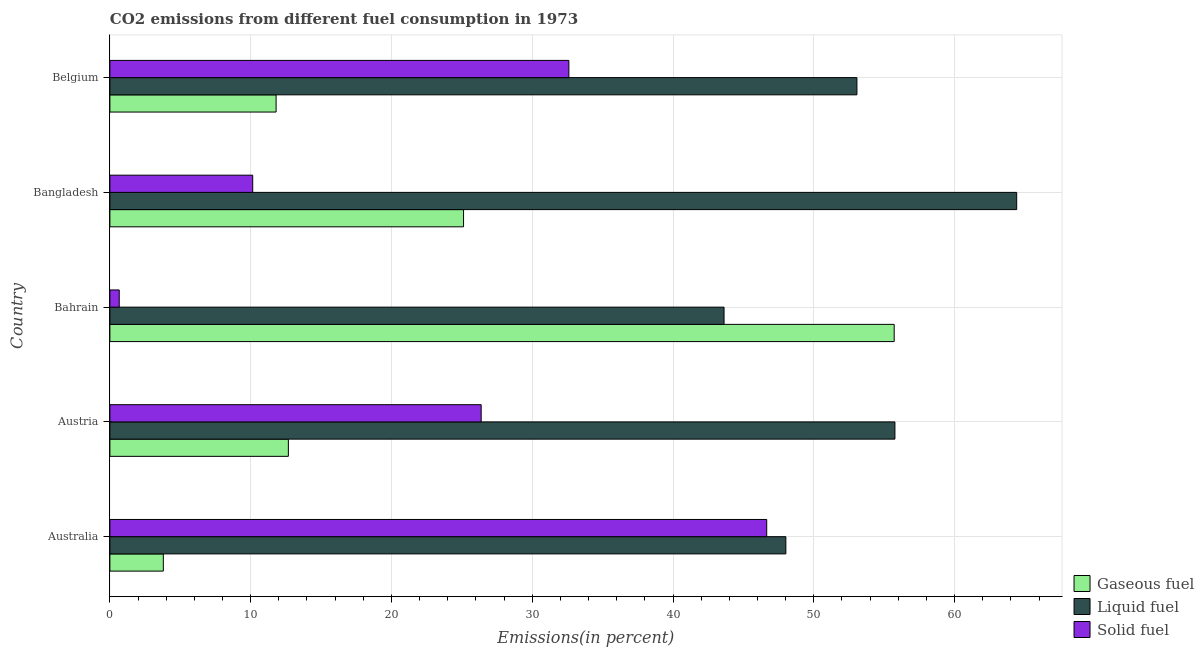How many different coloured bars are there?
Offer a terse response. 3. Are the number of bars per tick equal to the number of legend labels?
Ensure brevity in your answer.  Yes. Are the number of bars on each tick of the Y-axis equal?
Ensure brevity in your answer.  Yes. How many bars are there on the 3rd tick from the top?
Give a very brief answer. 3. How many bars are there on the 5th tick from the bottom?
Your answer should be compact. 3. In how many cases, is the number of bars for a given country not equal to the number of legend labels?
Provide a short and direct response. 0. What is the percentage of solid fuel emission in Belgium?
Provide a short and direct response. 32.6. Across all countries, what is the maximum percentage of liquid fuel emission?
Provide a short and direct response. 64.41. Across all countries, what is the minimum percentage of liquid fuel emission?
Your response must be concise. 43.63. In which country was the percentage of gaseous fuel emission maximum?
Provide a short and direct response. Bahrain. In which country was the percentage of liquid fuel emission minimum?
Your answer should be very brief. Bahrain. What is the total percentage of gaseous fuel emission in the graph?
Give a very brief answer. 109.11. What is the difference between the percentage of liquid fuel emission in Australia and that in Austria?
Ensure brevity in your answer.  -7.75. What is the difference between the percentage of gaseous fuel emission in Australia and the percentage of solid fuel emission in Austria?
Your response must be concise. -22.58. What is the average percentage of liquid fuel emission per country?
Ensure brevity in your answer.  52.98. What is the difference between the percentage of liquid fuel emission and percentage of solid fuel emission in Austria?
Give a very brief answer. 29.39. In how many countries, is the percentage of gaseous fuel emission greater than 58 %?
Your response must be concise. 0. What is the ratio of the percentage of gaseous fuel emission in Australia to that in Bahrain?
Make the answer very short. 0.07. What is the difference between the highest and the second highest percentage of gaseous fuel emission?
Make the answer very short. 30.59. What is the difference between the highest and the lowest percentage of solid fuel emission?
Ensure brevity in your answer.  45.99. In how many countries, is the percentage of gaseous fuel emission greater than the average percentage of gaseous fuel emission taken over all countries?
Give a very brief answer. 2. What does the 2nd bar from the top in Belgium represents?
Keep it short and to the point. Liquid fuel. What does the 1st bar from the bottom in Austria represents?
Provide a short and direct response. Gaseous fuel. Is it the case that in every country, the sum of the percentage of gaseous fuel emission and percentage of liquid fuel emission is greater than the percentage of solid fuel emission?
Your response must be concise. Yes. How many bars are there?
Offer a very short reply. 15. Are all the bars in the graph horizontal?
Your answer should be compact. Yes. How many countries are there in the graph?
Your answer should be very brief. 5. Does the graph contain any zero values?
Your answer should be very brief. No. What is the title of the graph?
Provide a short and direct response. CO2 emissions from different fuel consumption in 1973. What is the label or title of the X-axis?
Make the answer very short. Emissions(in percent). What is the label or title of the Y-axis?
Your answer should be compact. Country. What is the Emissions(in percent) in Gaseous fuel in Australia?
Your response must be concise. 3.8. What is the Emissions(in percent) of Liquid fuel in Australia?
Your answer should be very brief. 48.02. What is the Emissions(in percent) in Solid fuel in Australia?
Offer a very short reply. 46.66. What is the Emissions(in percent) in Gaseous fuel in Austria?
Offer a terse response. 12.68. What is the Emissions(in percent) of Liquid fuel in Austria?
Keep it short and to the point. 55.76. What is the Emissions(in percent) in Solid fuel in Austria?
Offer a terse response. 26.37. What is the Emissions(in percent) of Gaseous fuel in Bahrain?
Your answer should be compact. 55.71. What is the Emissions(in percent) of Liquid fuel in Bahrain?
Provide a short and direct response. 43.63. What is the Emissions(in percent) of Solid fuel in Bahrain?
Your response must be concise. 0.66. What is the Emissions(in percent) in Gaseous fuel in Bangladesh?
Your response must be concise. 25.12. What is the Emissions(in percent) in Liquid fuel in Bangladesh?
Your response must be concise. 64.41. What is the Emissions(in percent) of Solid fuel in Bangladesh?
Offer a terse response. 10.14. What is the Emissions(in percent) of Gaseous fuel in Belgium?
Your answer should be compact. 11.81. What is the Emissions(in percent) in Liquid fuel in Belgium?
Your answer should be compact. 53.06. What is the Emissions(in percent) in Solid fuel in Belgium?
Provide a short and direct response. 32.6. Across all countries, what is the maximum Emissions(in percent) of Gaseous fuel?
Your answer should be compact. 55.71. Across all countries, what is the maximum Emissions(in percent) in Liquid fuel?
Your answer should be compact. 64.41. Across all countries, what is the maximum Emissions(in percent) in Solid fuel?
Provide a succinct answer. 46.66. Across all countries, what is the minimum Emissions(in percent) of Gaseous fuel?
Ensure brevity in your answer.  3.8. Across all countries, what is the minimum Emissions(in percent) in Liquid fuel?
Make the answer very short. 43.63. Across all countries, what is the minimum Emissions(in percent) of Solid fuel?
Give a very brief answer. 0.66. What is the total Emissions(in percent) of Gaseous fuel in the graph?
Give a very brief answer. 109.11. What is the total Emissions(in percent) in Liquid fuel in the graph?
Make the answer very short. 264.88. What is the total Emissions(in percent) of Solid fuel in the graph?
Provide a succinct answer. 116.44. What is the difference between the Emissions(in percent) in Gaseous fuel in Australia and that in Austria?
Offer a very short reply. -8.88. What is the difference between the Emissions(in percent) in Liquid fuel in Australia and that in Austria?
Provide a short and direct response. -7.75. What is the difference between the Emissions(in percent) of Solid fuel in Australia and that in Austria?
Provide a succinct answer. 20.28. What is the difference between the Emissions(in percent) in Gaseous fuel in Australia and that in Bahrain?
Your response must be concise. -51.91. What is the difference between the Emissions(in percent) in Liquid fuel in Australia and that in Bahrain?
Offer a very short reply. 4.39. What is the difference between the Emissions(in percent) of Solid fuel in Australia and that in Bahrain?
Provide a short and direct response. 45.99. What is the difference between the Emissions(in percent) of Gaseous fuel in Australia and that in Bangladesh?
Ensure brevity in your answer.  -21.32. What is the difference between the Emissions(in percent) in Liquid fuel in Australia and that in Bangladesh?
Your answer should be very brief. -16.4. What is the difference between the Emissions(in percent) in Solid fuel in Australia and that in Bangladesh?
Offer a very short reply. 36.51. What is the difference between the Emissions(in percent) of Gaseous fuel in Australia and that in Belgium?
Your answer should be compact. -8.01. What is the difference between the Emissions(in percent) of Liquid fuel in Australia and that in Belgium?
Make the answer very short. -5.05. What is the difference between the Emissions(in percent) in Solid fuel in Australia and that in Belgium?
Make the answer very short. 14.05. What is the difference between the Emissions(in percent) in Gaseous fuel in Austria and that in Bahrain?
Offer a very short reply. -43.03. What is the difference between the Emissions(in percent) of Liquid fuel in Austria and that in Bahrain?
Give a very brief answer. 12.14. What is the difference between the Emissions(in percent) in Solid fuel in Austria and that in Bahrain?
Provide a short and direct response. 25.71. What is the difference between the Emissions(in percent) of Gaseous fuel in Austria and that in Bangladesh?
Ensure brevity in your answer.  -12.44. What is the difference between the Emissions(in percent) in Liquid fuel in Austria and that in Bangladesh?
Your answer should be very brief. -8.65. What is the difference between the Emissions(in percent) in Solid fuel in Austria and that in Bangladesh?
Ensure brevity in your answer.  16.23. What is the difference between the Emissions(in percent) of Gaseous fuel in Austria and that in Belgium?
Your answer should be very brief. 0.87. What is the difference between the Emissions(in percent) in Liquid fuel in Austria and that in Belgium?
Keep it short and to the point. 2.7. What is the difference between the Emissions(in percent) of Solid fuel in Austria and that in Belgium?
Offer a very short reply. -6.23. What is the difference between the Emissions(in percent) in Gaseous fuel in Bahrain and that in Bangladesh?
Your answer should be very brief. 30.59. What is the difference between the Emissions(in percent) in Liquid fuel in Bahrain and that in Bangladesh?
Provide a short and direct response. -20.79. What is the difference between the Emissions(in percent) in Solid fuel in Bahrain and that in Bangladesh?
Make the answer very short. -9.48. What is the difference between the Emissions(in percent) of Gaseous fuel in Bahrain and that in Belgium?
Your response must be concise. 43.9. What is the difference between the Emissions(in percent) of Liquid fuel in Bahrain and that in Belgium?
Give a very brief answer. -9.44. What is the difference between the Emissions(in percent) of Solid fuel in Bahrain and that in Belgium?
Offer a terse response. -31.94. What is the difference between the Emissions(in percent) in Gaseous fuel in Bangladesh and that in Belgium?
Your answer should be very brief. 13.31. What is the difference between the Emissions(in percent) of Liquid fuel in Bangladesh and that in Belgium?
Make the answer very short. 11.35. What is the difference between the Emissions(in percent) in Solid fuel in Bangladesh and that in Belgium?
Give a very brief answer. -22.46. What is the difference between the Emissions(in percent) of Gaseous fuel in Australia and the Emissions(in percent) of Liquid fuel in Austria?
Make the answer very short. -51.97. What is the difference between the Emissions(in percent) in Gaseous fuel in Australia and the Emissions(in percent) in Solid fuel in Austria?
Offer a terse response. -22.58. What is the difference between the Emissions(in percent) in Liquid fuel in Australia and the Emissions(in percent) in Solid fuel in Austria?
Your answer should be compact. 21.64. What is the difference between the Emissions(in percent) in Gaseous fuel in Australia and the Emissions(in percent) in Liquid fuel in Bahrain?
Give a very brief answer. -39.83. What is the difference between the Emissions(in percent) of Gaseous fuel in Australia and the Emissions(in percent) of Solid fuel in Bahrain?
Offer a terse response. 3.13. What is the difference between the Emissions(in percent) in Liquid fuel in Australia and the Emissions(in percent) in Solid fuel in Bahrain?
Offer a very short reply. 47.35. What is the difference between the Emissions(in percent) of Gaseous fuel in Australia and the Emissions(in percent) of Liquid fuel in Bangladesh?
Offer a terse response. -60.62. What is the difference between the Emissions(in percent) in Gaseous fuel in Australia and the Emissions(in percent) in Solid fuel in Bangladesh?
Your answer should be compact. -6.35. What is the difference between the Emissions(in percent) in Liquid fuel in Australia and the Emissions(in percent) in Solid fuel in Bangladesh?
Provide a succinct answer. 37.87. What is the difference between the Emissions(in percent) in Gaseous fuel in Australia and the Emissions(in percent) in Liquid fuel in Belgium?
Keep it short and to the point. -49.27. What is the difference between the Emissions(in percent) in Gaseous fuel in Australia and the Emissions(in percent) in Solid fuel in Belgium?
Make the answer very short. -28.81. What is the difference between the Emissions(in percent) of Liquid fuel in Australia and the Emissions(in percent) of Solid fuel in Belgium?
Provide a succinct answer. 15.41. What is the difference between the Emissions(in percent) of Gaseous fuel in Austria and the Emissions(in percent) of Liquid fuel in Bahrain?
Offer a terse response. -30.95. What is the difference between the Emissions(in percent) of Gaseous fuel in Austria and the Emissions(in percent) of Solid fuel in Bahrain?
Give a very brief answer. 12.01. What is the difference between the Emissions(in percent) of Liquid fuel in Austria and the Emissions(in percent) of Solid fuel in Bahrain?
Offer a very short reply. 55.1. What is the difference between the Emissions(in percent) of Gaseous fuel in Austria and the Emissions(in percent) of Liquid fuel in Bangladesh?
Give a very brief answer. -51.73. What is the difference between the Emissions(in percent) in Gaseous fuel in Austria and the Emissions(in percent) in Solid fuel in Bangladesh?
Offer a terse response. 2.53. What is the difference between the Emissions(in percent) in Liquid fuel in Austria and the Emissions(in percent) in Solid fuel in Bangladesh?
Provide a short and direct response. 45.62. What is the difference between the Emissions(in percent) of Gaseous fuel in Austria and the Emissions(in percent) of Liquid fuel in Belgium?
Provide a succinct answer. -40.39. What is the difference between the Emissions(in percent) in Gaseous fuel in Austria and the Emissions(in percent) in Solid fuel in Belgium?
Offer a very short reply. -19.93. What is the difference between the Emissions(in percent) of Liquid fuel in Austria and the Emissions(in percent) of Solid fuel in Belgium?
Provide a succinct answer. 23.16. What is the difference between the Emissions(in percent) of Gaseous fuel in Bahrain and the Emissions(in percent) of Liquid fuel in Bangladesh?
Offer a very short reply. -8.7. What is the difference between the Emissions(in percent) in Gaseous fuel in Bahrain and the Emissions(in percent) in Solid fuel in Bangladesh?
Your answer should be compact. 45.57. What is the difference between the Emissions(in percent) in Liquid fuel in Bahrain and the Emissions(in percent) in Solid fuel in Bangladesh?
Your answer should be compact. 33.48. What is the difference between the Emissions(in percent) of Gaseous fuel in Bahrain and the Emissions(in percent) of Liquid fuel in Belgium?
Ensure brevity in your answer.  2.65. What is the difference between the Emissions(in percent) of Gaseous fuel in Bahrain and the Emissions(in percent) of Solid fuel in Belgium?
Provide a short and direct response. 23.11. What is the difference between the Emissions(in percent) of Liquid fuel in Bahrain and the Emissions(in percent) of Solid fuel in Belgium?
Offer a very short reply. 11.02. What is the difference between the Emissions(in percent) in Gaseous fuel in Bangladesh and the Emissions(in percent) in Liquid fuel in Belgium?
Provide a succinct answer. -27.94. What is the difference between the Emissions(in percent) in Gaseous fuel in Bangladesh and the Emissions(in percent) in Solid fuel in Belgium?
Provide a short and direct response. -7.48. What is the difference between the Emissions(in percent) in Liquid fuel in Bangladesh and the Emissions(in percent) in Solid fuel in Belgium?
Ensure brevity in your answer.  31.81. What is the average Emissions(in percent) of Gaseous fuel per country?
Make the answer very short. 21.82. What is the average Emissions(in percent) in Liquid fuel per country?
Give a very brief answer. 52.98. What is the average Emissions(in percent) of Solid fuel per country?
Your response must be concise. 23.29. What is the difference between the Emissions(in percent) in Gaseous fuel and Emissions(in percent) in Liquid fuel in Australia?
Offer a very short reply. -44.22. What is the difference between the Emissions(in percent) of Gaseous fuel and Emissions(in percent) of Solid fuel in Australia?
Give a very brief answer. -42.86. What is the difference between the Emissions(in percent) in Liquid fuel and Emissions(in percent) in Solid fuel in Australia?
Keep it short and to the point. 1.36. What is the difference between the Emissions(in percent) in Gaseous fuel and Emissions(in percent) in Liquid fuel in Austria?
Your answer should be compact. -43.09. What is the difference between the Emissions(in percent) of Gaseous fuel and Emissions(in percent) of Solid fuel in Austria?
Provide a short and direct response. -13.7. What is the difference between the Emissions(in percent) in Liquid fuel and Emissions(in percent) in Solid fuel in Austria?
Your answer should be compact. 29.39. What is the difference between the Emissions(in percent) in Gaseous fuel and Emissions(in percent) in Liquid fuel in Bahrain?
Give a very brief answer. 12.09. What is the difference between the Emissions(in percent) of Gaseous fuel and Emissions(in percent) of Solid fuel in Bahrain?
Your answer should be compact. 55.05. What is the difference between the Emissions(in percent) in Liquid fuel and Emissions(in percent) in Solid fuel in Bahrain?
Your response must be concise. 42.96. What is the difference between the Emissions(in percent) of Gaseous fuel and Emissions(in percent) of Liquid fuel in Bangladesh?
Your answer should be very brief. -39.29. What is the difference between the Emissions(in percent) of Gaseous fuel and Emissions(in percent) of Solid fuel in Bangladesh?
Give a very brief answer. 14.98. What is the difference between the Emissions(in percent) of Liquid fuel and Emissions(in percent) of Solid fuel in Bangladesh?
Your answer should be compact. 54.27. What is the difference between the Emissions(in percent) in Gaseous fuel and Emissions(in percent) in Liquid fuel in Belgium?
Your answer should be very brief. -41.26. What is the difference between the Emissions(in percent) of Gaseous fuel and Emissions(in percent) of Solid fuel in Belgium?
Make the answer very short. -20.8. What is the difference between the Emissions(in percent) in Liquid fuel and Emissions(in percent) in Solid fuel in Belgium?
Ensure brevity in your answer.  20.46. What is the ratio of the Emissions(in percent) in Gaseous fuel in Australia to that in Austria?
Provide a short and direct response. 0.3. What is the ratio of the Emissions(in percent) in Liquid fuel in Australia to that in Austria?
Your answer should be very brief. 0.86. What is the ratio of the Emissions(in percent) of Solid fuel in Australia to that in Austria?
Offer a very short reply. 1.77. What is the ratio of the Emissions(in percent) in Gaseous fuel in Australia to that in Bahrain?
Ensure brevity in your answer.  0.07. What is the ratio of the Emissions(in percent) of Liquid fuel in Australia to that in Bahrain?
Your answer should be compact. 1.1. What is the ratio of the Emissions(in percent) of Solid fuel in Australia to that in Bahrain?
Make the answer very short. 70.26. What is the ratio of the Emissions(in percent) of Gaseous fuel in Australia to that in Bangladesh?
Offer a terse response. 0.15. What is the ratio of the Emissions(in percent) of Liquid fuel in Australia to that in Bangladesh?
Offer a terse response. 0.75. What is the ratio of the Emissions(in percent) of Solid fuel in Australia to that in Bangladesh?
Ensure brevity in your answer.  4.6. What is the ratio of the Emissions(in percent) of Gaseous fuel in Australia to that in Belgium?
Give a very brief answer. 0.32. What is the ratio of the Emissions(in percent) of Liquid fuel in Australia to that in Belgium?
Make the answer very short. 0.9. What is the ratio of the Emissions(in percent) of Solid fuel in Australia to that in Belgium?
Ensure brevity in your answer.  1.43. What is the ratio of the Emissions(in percent) of Gaseous fuel in Austria to that in Bahrain?
Your answer should be very brief. 0.23. What is the ratio of the Emissions(in percent) in Liquid fuel in Austria to that in Bahrain?
Provide a short and direct response. 1.28. What is the ratio of the Emissions(in percent) in Solid fuel in Austria to that in Bahrain?
Your answer should be compact. 39.72. What is the ratio of the Emissions(in percent) of Gaseous fuel in Austria to that in Bangladesh?
Provide a succinct answer. 0.5. What is the ratio of the Emissions(in percent) in Liquid fuel in Austria to that in Bangladesh?
Ensure brevity in your answer.  0.87. What is the ratio of the Emissions(in percent) in Solid fuel in Austria to that in Bangladesh?
Offer a terse response. 2.6. What is the ratio of the Emissions(in percent) in Gaseous fuel in Austria to that in Belgium?
Offer a terse response. 1.07. What is the ratio of the Emissions(in percent) of Liquid fuel in Austria to that in Belgium?
Provide a succinct answer. 1.05. What is the ratio of the Emissions(in percent) in Solid fuel in Austria to that in Belgium?
Ensure brevity in your answer.  0.81. What is the ratio of the Emissions(in percent) of Gaseous fuel in Bahrain to that in Bangladesh?
Your response must be concise. 2.22. What is the ratio of the Emissions(in percent) in Liquid fuel in Bahrain to that in Bangladesh?
Make the answer very short. 0.68. What is the ratio of the Emissions(in percent) of Solid fuel in Bahrain to that in Bangladesh?
Provide a short and direct response. 0.07. What is the ratio of the Emissions(in percent) in Gaseous fuel in Bahrain to that in Belgium?
Provide a short and direct response. 4.72. What is the ratio of the Emissions(in percent) in Liquid fuel in Bahrain to that in Belgium?
Your response must be concise. 0.82. What is the ratio of the Emissions(in percent) in Solid fuel in Bahrain to that in Belgium?
Ensure brevity in your answer.  0.02. What is the ratio of the Emissions(in percent) of Gaseous fuel in Bangladesh to that in Belgium?
Give a very brief answer. 2.13. What is the ratio of the Emissions(in percent) of Liquid fuel in Bangladesh to that in Belgium?
Offer a very short reply. 1.21. What is the ratio of the Emissions(in percent) in Solid fuel in Bangladesh to that in Belgium?
Provide a short and direct response. 0.31. What is the difference between the highest and the second highest Emissions(in percent) of Gaseous fuel?
Give a very brief answer. 30.59. What is the difference between the highest and the second highest Emissions(in percent) in Liquid fuel?
Your response must be concise. 8.65. What is the difference between the highest and the second highest Emissions(in percent) of Solid fuel?
Your answer should be compact. 14.05. What is the difference between the highest and the lowest Emissions(in percent) of Gaseous fuel?
Your answer should be compact. 51.91. What is the difference between the highest and the lowest Emissions(in percent) of Liquid fuel?
Provide a short and direct response. 20.79. What is the difference between the highest and the lowest Emissions(in percent) of Solid fuel?
Keep it short and to the point. 45.99. 